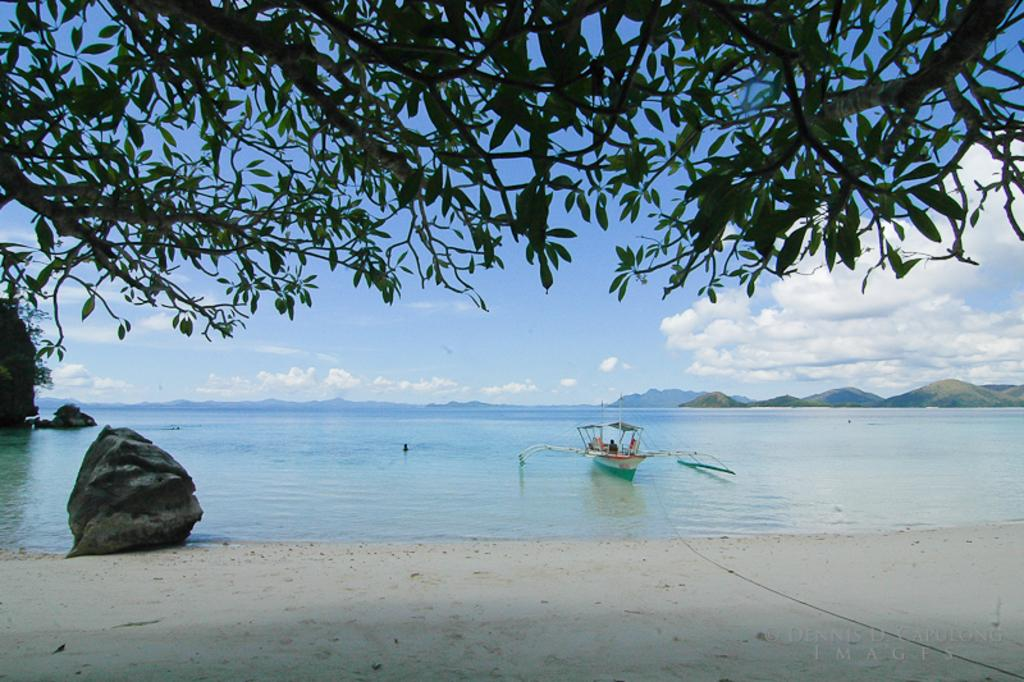What type of surface can be seen in the image? Ground and water are visible in the image. What natural element is present in the image? There is a tree in the image. What is floating on the water in the image? There is a white-colored boat in the water. What can be seen in the background of the image? Clouds and the sky are visible in the background. Is there any text or marking on the image? Yes, there is a watermark in the image. What type of feeling does the wax have in the image? There is no wax present in the image, so it is not possible to determine the feeling of any wax. 